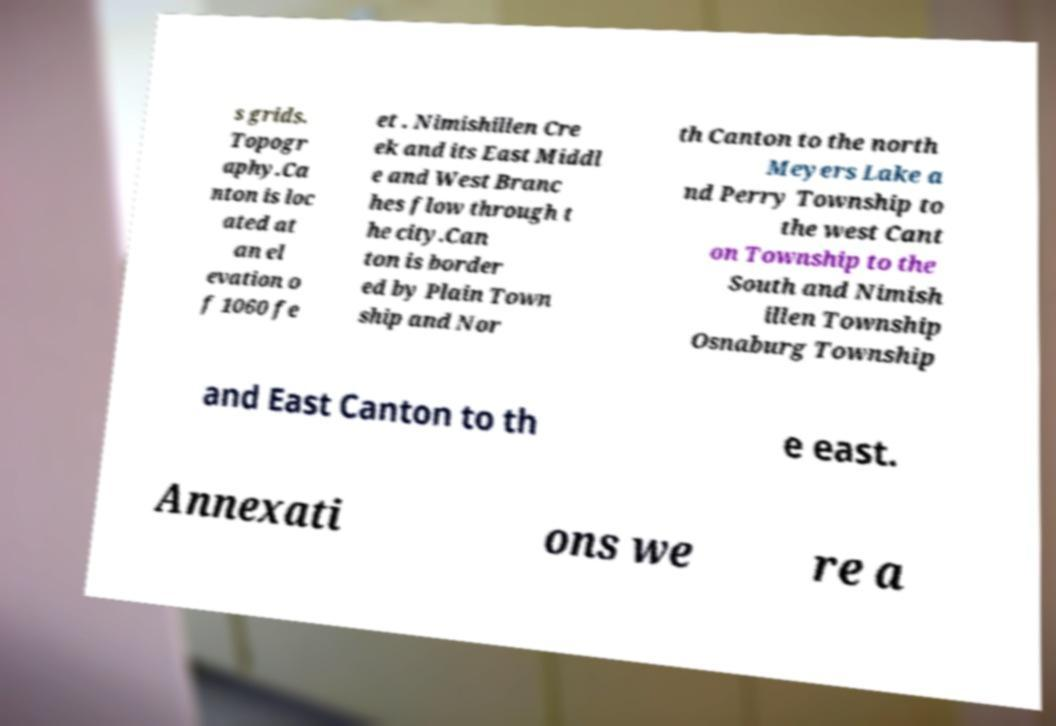Can you read and provide the text displayed in the image?This photo seems to have some interesting text. Can you extract and type it out for me? s grids. Topogr aphy.Ca nton is loc ated at an el evation o f 1060 fe et . Nimishillen Cre ek and its East Middl e and West Branc hes flow through t he city.Can ton is border ed by Plain Town ship and Nor th Canton to the north Meyers Lake a nd Perry Township to the west Cant on Township to the South and Nimish illen Township Osnaburg Township and East Canton to th e east. Annexati ons we re a 